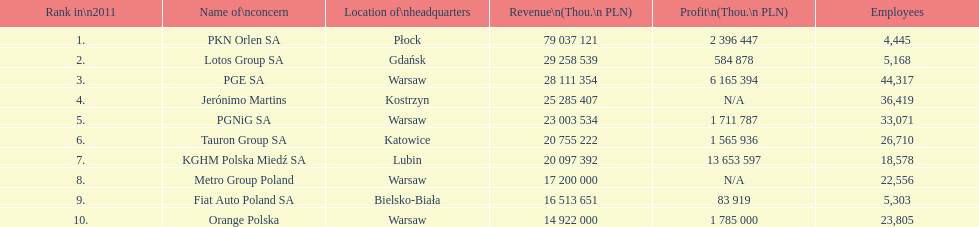Which firm had the lowest revenue? Orange Polska. 